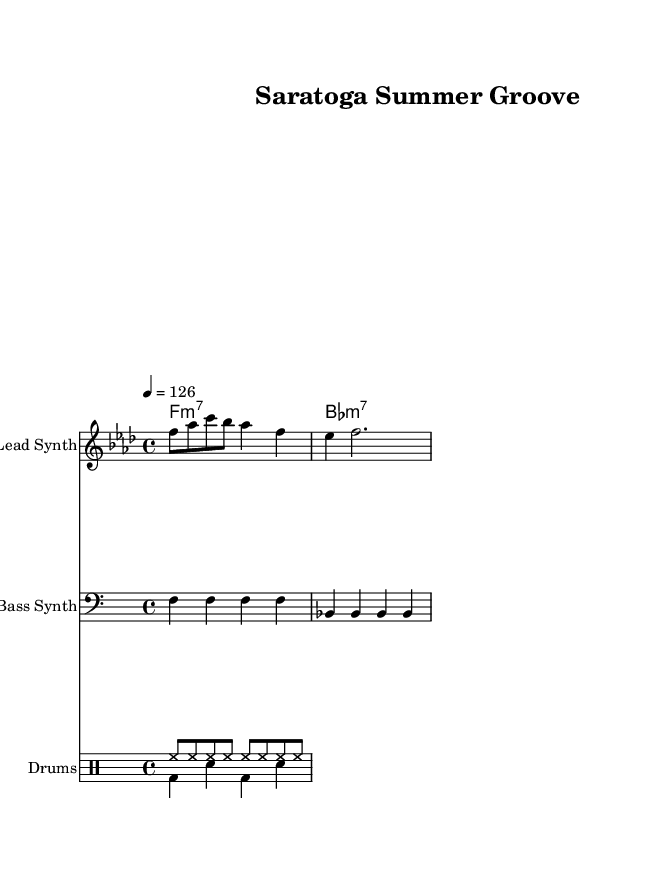What is the key signature of this music? The key signature is indicated at the beginning of the sheet music. In this case, it shows two flats, which means the key signature is B flat major or G minor. However, since the overall tonality is based on F minor, it's correct to say that the key signature helps to confirm this.
Answer: F minor What is the time signature of this piece? The time signature is represented at the beginning of the sheet music. It is shown as 4/4, which means there are four beats per measure and the quarter note gets one beat.
Answer: 4/4 What tempo marking does this music have? The tempo marking is found at the beginning of the score, noted as a quarter note equals 126 beats per minute. This indicates how fast the piece should be played.
Answer: 126 How many measures are there in the melody? To find the number of measures, we can count the bars in the melody line. Each line in the staff represents the musical measures, so a quick count shows there are five measures in total.
Answer: 5 What is the bass line rhythm pattern? The bass line is written in a continuous pattern of quarter notes, which are consistent throughout the first and second measures. By looking at the rhythm and timbre, it is clear that the bass line plays a repetitive sequence typical of house music.
Answer: Repetitive quarter notes How many different drum patterns are indicated in the drum staff? By examining the drum staff, we observe two distinct layers of rhythms. The first indicates a consistent hi-hat pattern, while the second indicates a kick-snare combination. Count shows there are two distinct patterns represented.
Answer: 2 What style of music does this sheet represent? The characteristics such as the use of funky rhythm in the bassline and drum patterns alongside synthesizer elements point towards house music, particularly fitting for summer festivals. By analyzing the genre indicators, it's clear this is disco house music.
Answer: Disco house 